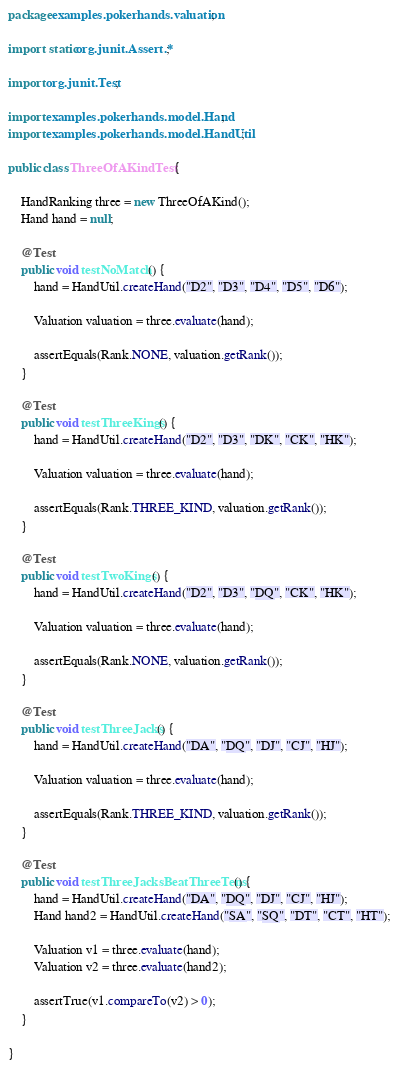Convert code to text. <code><loc_0><loc_0><loc_500><loc_500><_Java_>package examples.pokerhands.valuation;

import static org.junit.Assert.*;

import org.junit.Test;

import examples.pokerhands.model.Hand;
import examples.pokerhands.model.HandUtil;

public class ThreeOfAKindTest {

	HandRanking three = new ThreeOfAKind();
	Hand hand = null;

	@Test
	public void testNoMatch() {
		hand = HandUtil.createHand("D2", "D3", "D4", "D5", "D6");

		Valuation valuation = three.evaluate(hand);

		assertEquals(Rank.NONE, valuation.getRank());
	}

	@Test
	public void testThreeKings() {
		hand = HandUtil.createHand("D2", "D3", "DK", "CK", "HK");

		Valuation valuation = three.evaluate(hand);

		assertEquals(Rank.THREE_KIND, valuation.getRank());
	}

	@Test
	public void testTwoKings() {
		hand = HandUtil.createHand("D2", "D3", "DQ", "CK", "HK");

		Valuation valuation = three.evaluate(hand);

		assertEquals(Rank.NONE, valuation.getRank());
	}

	@Test
	public void testThreeJacks() {
		hand = HandUtil.createHand("DA", "DQ", "DJ", "CJ", "HJ");

		Valuation valuation = three.evaluate(hand);

		assertEquals(Rank.THREE_KIND, valuation.getRank());
	}

	@Test
	public void testThreeJacksBeatThreeTens() {
		hand = HandUtil.createHand("DA", "DQ", "DJ", "CJ", "HJ");
		Hand hand2 = HandUtil.createHand("SA", "SQ", "DT", "CT", "HT");

		Valuation v1 = three.evaluate(hand);
		Valuation v2 = three.evaluate(hand2);

		assertTrue(v1.compareTo(v2) > 0);
	}

}
</code> 